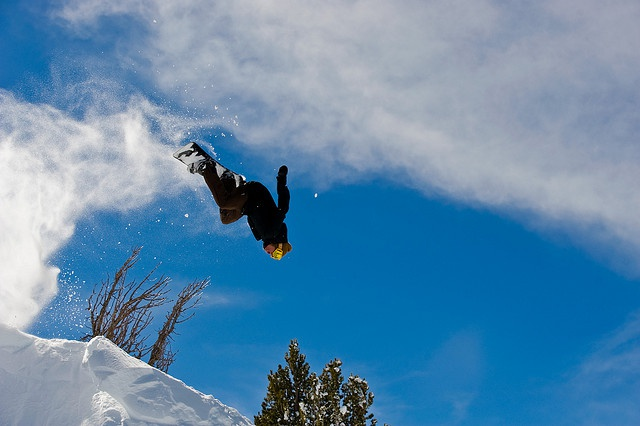Describe the objects in this image and their specific colors. I can see people in blue, black, teal, darkgray, and gray tones and snowboard in blue, darkgray, black, lightgray, and gray tones in this image. 